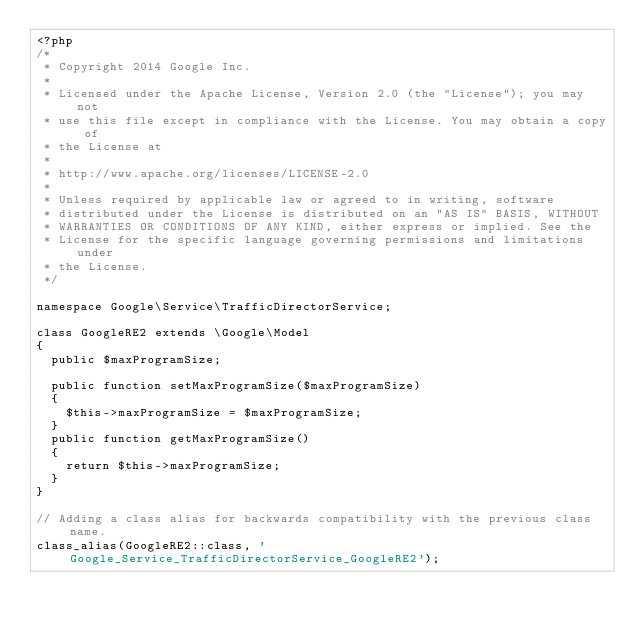Convert code to text. <code><loc_0><loc_0><loc_500><loc_500><_PHP_><?php
/*
 * Copyright 2014 Google Inc.
 *
 * Licensed under the Apache License, Version 2.0 (the "License"); you may not
 * use this file except in compliance with the License. You may obtain a copy of
 * the License at
 *
 * http://www.apache.org/licenses/LICENSE-2.0
 *
 * Unless required by applicable law or agreed to in writing, software
 * distributed under the License is distributed on an "AS IS" BASIS, WITHOUT
 * WARRANTIES OR CONDITIONS OF ANY KIND, either express or implied. See the
 * License for the specific language governing permissions and limitations under
 * the License.
 */

namespace Google\Service\TrafficDirectorService;

class GoogleRE2 extends \Google\Model
{
  public $maxProgramSize;

  public function setMaxProgramSize($maxProgramSize)
  {
    $this->maxProgramSize = $maxProgramSize;
  }
  public function getMaxProgramSize()
  {
    return $this->maxProgramSize;
  }
}

// Adding a class alias for backwards compatibility with the previous class name.
class_alias(GoogleRE2::class, 'Google_Service_TrafficDirectorService_GoogleRE2');
</code> 